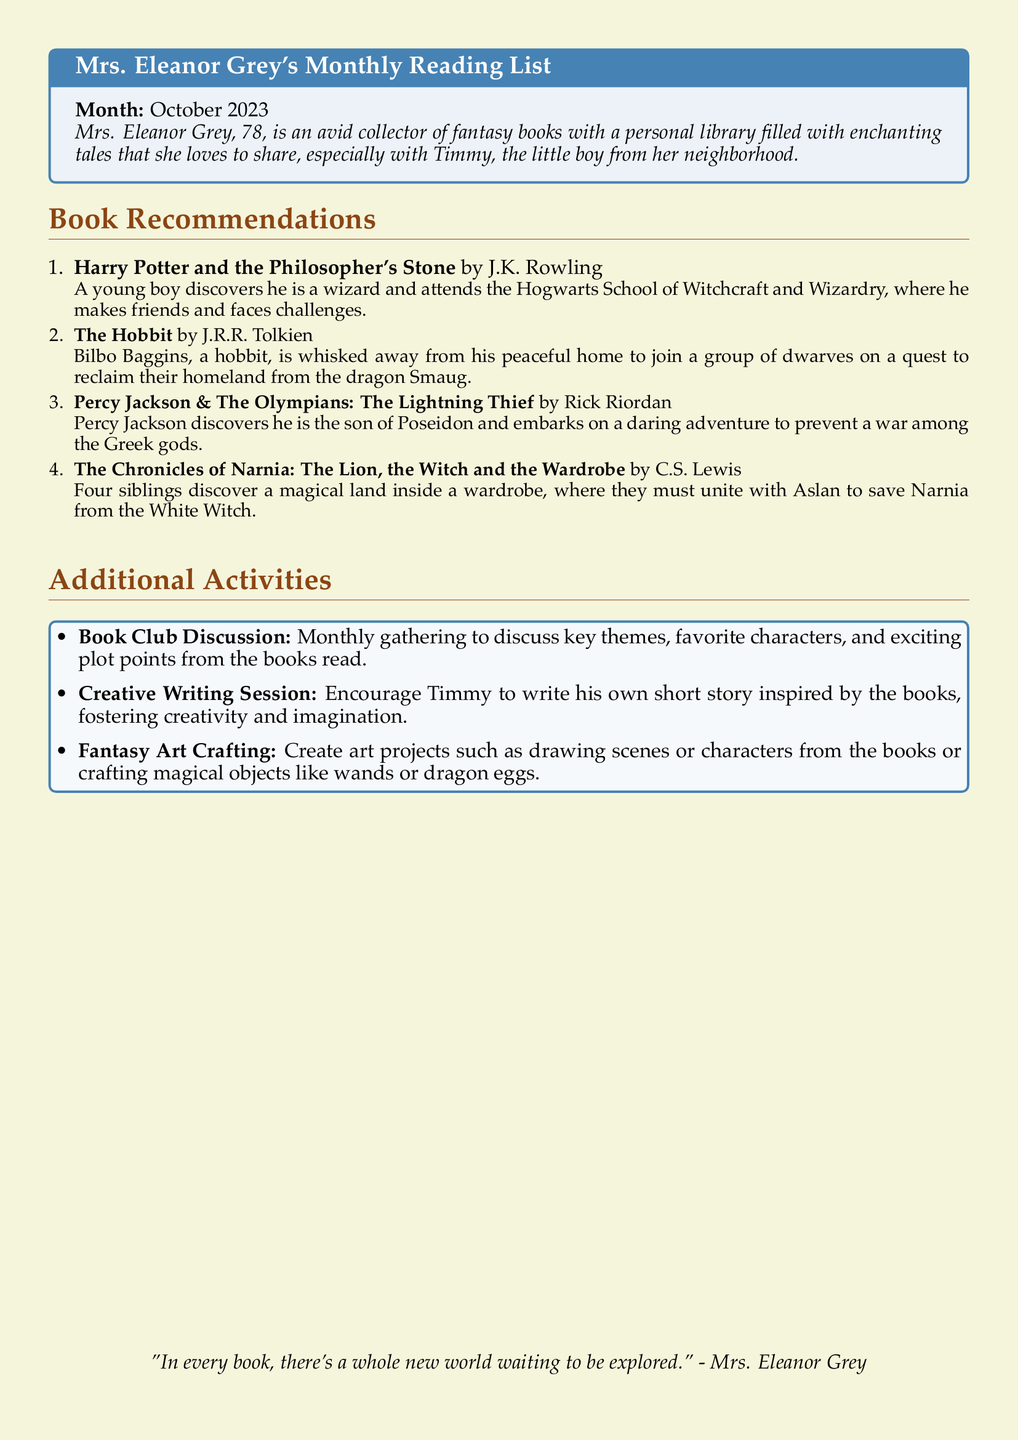What is the month of the reading list? The month listed at the top of the reading list is explicitly stated in the document as October 2023.
Answer: October 2023 Who is the author of "The Hobbit"? The author of "The Hobbit" is mentioned in the recommendations section of the document.
Answer: J.R.R. Tolkien What is the main theme of "Harry Potter and the Philosopher's Stone"? The theme involves a young boy discovering his wizard identity and attending a magical school, which is highlighted in the summary provided.
Answer: Discovery of magic What activity encourages Timmy to be creative? The document mentions a specific activity aimed at fostering Timmy's creativity through story writing.
Answer: Creative Writing Session How many book recommendations are listed? The number of book recommendations is determined by counting each listed item in the recommendations section.
Answer: Four 